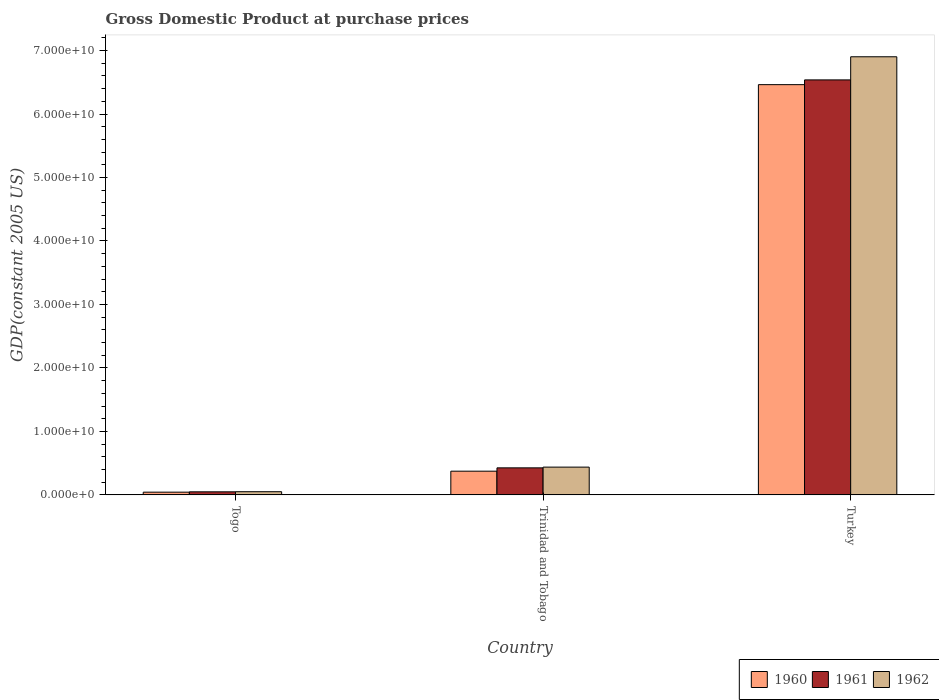How many different coloured bars are there?
Your response must be concise. 3. How many groups of bars are there?
Offer a terse response. 3. What is the label of the 3rd group of bars from the left?
Your answer should be very brief. Turkey. In how many cases, is the number of bars for a given country not equal to the number of legend labels?
Your response must be concise. 0. What is the GDP at purchase prices in 1962 in Trinidad and Tobago?
Make the answer very short. 4.38e+09. Across all countries, what is the maximum GDP at purchase prices in 1960?
Make the answer very short. 6.46e+1. Across all countries, what is the minimum GDP at purchase prices in 1961?
Your response must be concise. 4.83e+08. In which country was the GDP at purchase prices in 1960 maximum?
Provide a succinct answer. Turkey. In which country was the GDP at purchase prices in 1962 minimum?
Make the answer very short. Togo. What is the total GDP at purchase prices in 1960 in the graph?
Offer a terse response. 6.88e+1. What is the difference between the GDP at purchase prices in 1962 in Togo and that in Turkey?
Your answer should be compact. -6.85e+1. What is the difference between the GDP at purchase prices in 1960 in Turkey and the GDP at purchase prices in 1962 in Togo?
Your answer should be very brief. 6.41e+1. What is the average GDP at purchase prices in 1961 per country?
Ensure brevity in your answer.  2.34e+1. What is the difference between the GDP at purchase prices of/in 1962 and GDP at purchase prices of/in 1960 in Trinidad and Tobago?
Give a very brief answer. 6.41e+08. What is the ratio of the GDP at purchase prices in 1960 in Togo to that in Turkey?
Your answer should be compact. 0.01. Is the GDP at purchase prices in 1961 in Trinidad and Tobago less than that in Turkey?
Provide a succinct answer. Yes. Is the difference between the GDP at purchase prices in 1962 in Togo and Trinidad and Tobago greater than the difference between the GDP at purchase prices in 1960 in Togo and Trinidad and Tobago?
Keep it short and to the point. No. What is the difference between the highest and the second highest GDP at purchase prices in 1961?
Offer a terse response. 6.11e+1. What is the difference between the highest and the lowest GDP at purchase prices in 1960?
Ensure brevity in your answer.  6.42e+1. Is the sum of the GDP at purchase prices in 1960 in Togo and Turkey greater than the maximum GDP at purchase prices in 1962 across all countries?
Offer a terse response. No. Is it the case that in every country, the sum of the GDP at purchase prices in 1960 and GDP at purchase prices in 1961 is greater than the GDP at purchase prices in 1962?
Offer a very short reply. Yes. How many bars are there?
Offer a terse response. 9. Are all the bars in the graph horizontal?
Make the answer very short. No. Are the values on the major ticks of Y-axis written in scientific E-notation?
Offer a very short reply. Yes. Does the graph contain any zero values?
Provide a succinct answer. No. Does the graph contain grids?
Keep it short and to the point. No. Where does the legend appear in the graph?
Your answer should be compact. Bottom right. How many legend labels are there?
Ensure brevity in your answer.  3. How are the legend labels stacked?
Your answer should be very brief. Horizontal. What is the title of the graph?
Your answer should be very brief. Gross Domestic Product at purchase prices. Does "2001" appear as one of the legend labels in the graph?
Offer a terse response. No. What is the label or title of the Y-axis?
Provide a short and direct response. GDP(constant 2005 US). What is the GDP(constant 2005 US) of 1960 in Togo?
Offer a very short reply. 4.31e+08. What is the GDP(constant 2005 US) of 1961 in Togo?
Keep it short and to the point. 4.83e+08. What is the GDP(constant 2005 US) in 1962 in Togo?
Offer a terse response. 5.01e+08. What is the GDP(constant 2005 US) of 1960 in Trinidad and Tobago?
Ensure brevity in your answer.  3.74e+09. What is the GDP(constant 2005 US) in 1961 in Trinidad and Tobago?
Your response must be concise. 4.26e+09. What is the GDP(constant 2005 US) of 1962 in Trinidad and Tobago?
Your answer should be compact. 4.38e+09. What is the GDP(constant 2005 US) of 1960 in Turkey?
Your answer should be compact. 6.46e+1. What is the GDP(constant 2005 US) in 1961 in Turkey?
Your response must be concise. 6.54e+1. What is the GDP(constant 2005 US) of 1962 in Turkey?
Your response must be concise. 6.90e+1. Across all countries, what is the maximum GDP(constant 2005 US) in 1960?
Provide a succinct answer. 6.46e+1. Across all countries, what is the maximum GDP(constant 2005 US) of 1961?
Your answer should be compact. 6.54e+1. Across all countries, what is the maximum GDP(constant 2005 US) of 1962?
Your response must be concise. 6.90e+1. Across all countries, what is the minimum GDP(constant 2005 US) of 1960?
Make the answer very short. 4.31e+08. Across all countries, what is the minimum GDP(constant 2005 US) of 1961?
Your answer should be compact. 4.83e+08. Across all countries, what is the minimum GDP(constant 2005 US) in 1962?
Your answer should be very brief. 5.01e+08. What is the total GDP(constant 2005 US) of 1960 in the graph?
Keep it short and to the point. 6.88e+1. What is the total GDP(constant 2005 US) in 1961 in the graph?
Keep it short and to the point. 7.01e+1. What is the total GDP(constant 2005 US) in 1962 in the graph?
Keep it short and to the point. 7.39e+1. What is the difference between the GDP(constant 2005 US) of 1960 in Togo and that in Trinidad and Tobago?
Ensure brevity in your answer.  -3.30e+09. What is the difference between the GDP(constant 2005 US) of 1961 in Togo and that in Trinidad and Tobago?
Keep it short and to the point. -3.78e+09. What is the difference between the GDP(constant 2005 US) in 1962 in Togo and that in Trinidad and Tobago?
Keep it short and to the point. -3.88e+09. What is the difference between the GDP(constant 2005 US) of 1960 in Togo and that in Turkey?
Give a very brief answer. -6.42e+1. What is the difference between the GDP(constant 2005 US) in 1961 in Togo and that in Turkey?
Offer a terse response. -6.49e+1. What is the difference between the GDP(constant 2005 US) in 1962 in Togo and that in Turkey?
Your response must be concise. -6.85e+1. What is the difference between the GDP(constant 2005 US) in 1960 in Trinidad and Tobago and that in Turkey?
Offer a very short reply. -6.09e+1. What is the difference between the GDP(constant 2005 US) in 1961 in Trinidad and Tobago and that in Turkey?
Provide a short and direct response. -6.11e+1. What is the difference between the GDP(constant 2005 US) in 1962 in Trinidad and Tobago and that in Turkey?
Make the answer very short. -6.46e+1. What is the difference between the GDP(constant 2005 US) in 1960 in Togo and the GDP(constant 2005 US) in 1961 in Trinidad and Tobago?
Ensure brevity in your answer.  -3.83e+09. What is the difference between the GDP(constant 2005 US) of 1960 in Togo and the GDP(constant 2005 US) of 1962 in Trinidad and Tobago?
Offer a very short reply. -3.95e+09. What is the difference between the GDP(constant 2005 US) of 1961 in Togo and the GDP(constant 2005 US) of 1962 in Trinidad and Tobago?
Offer a terse response. -3.89e+09. What is the difference between the GDP(constant 2005 US) of 1960 in Togo and the GDP(constant 2005 US) of 1961 in Turkey?
Keep it short and to the point. -6.49e+1. What is the difference between the GDP(constant 2005 US) in 1960 in Togo and the GDP(constant 2005 US) in 1962 in Turkey?
Your answer should be very brief. -6.86e+1. What is the difference between the GDP(constant 2005 US) in 1961 in Togo and the GDP(constant 2005 US) in 1962 in Turkey?
Make the answer very short. -6.85e+1. What is the difference between the GDP(constant 2005 US) in 1960 in Trinidad and Tobago and the GDP(constant 2005 US) in 1961 in Turkey?
Offer a very short reply. -6.16e+1. What is the difference between the GDP(constant 2005 US) in 1960 in Trinidad and Tobago and the GDP(constant 2005 US) in 1962 in Turkey?
Offer a terse response. -6.53e+1. What is the difference between the GDP(constant 2005 US) in 1961 in Trinidad and Tobago and the GDP(constant 2005 US) in 1962 in Turkey?
Your response must be concise. -6.48e+1. What is the average GDP(constant 2005 US) of 1960 per country?
Offer a terse response. 2.29e+1. What is the average GDP(constant 2005 US) of 1961 per country?
Ensure brevity in your answer.  2.34e+1. What is the average GDP(constant 2005 US) of 1962 per country?
Keep it short and to the point. 2.46e+1. What is the difference between the GDP(constant 2005 US) in 1960 and GDP(constant 2005 US) in 1961 in Togo?
Make the answer very short. -5.24e+07. What is the difference between the GDP(constant 2005 US) in 1960 and GDP(constant 2005 US) in 1962 in Togo?
Ensure brevity in your answer.  -7.06e+07. What is the difference between the GDP(constant 2005 US) of 1961 and GDP(constant 2005 US) of 1962 in Togo?
Keep it short and to the point. -1.82e+07. What is the difference between the GDP(constant 2005 US) of 1960 and GDP(constant 2005 US) of 1961 in Trinidad and Tobago?
Provide a succinct answer. -5.24e+08. What is the difference between the GDP(constant 2005 US) of 1960 and GDP(constant 2005 US) of 1962 in Trinidad and Tobago?
Provide a succinct answer. -6.41e+08. What is the difference between the GDP(constant 2005 US) in 1961 and GDP(constant 2005 US) in 1962 in Trinidad and Tobago?
Provide a succinct answer. -1.17e+08. What is the difference between the GDP(constant 2005 US) in 1960 and GDP(constant 2005 US) in 1961 in Turkey?
Ensure brevity in your answer.  -7.47e+08. What is the difference between the GDP(constant 2005 US) in 1960 and GDP(constant 2005 US) in 1962 in Turkey?
Give a very brief answer. -4.39e+09. What is the difference between the GDP(constant 2005 US) of 1961 and GDP(constant 2005 US) of 1962 in Turkey?
Ensure brevity in your answer.  -3.64e+09. What is the ratio of the GDP(constant 2005 US) in 1960 in Togo to that in Trinidad and Tobago?
Keep it short and to the point. 0.12. What is the ratio of the GDP(constant 2005 US) of 1961 in Togo to that in Trinidad and Tobago?
Make the answer very short. 0.11. What is the ratio of the GDP(constant 2005 US) in 1962 in Togo to that in Trinidad and Tobago?
Your answer should be very brief. 0.11. What is the ratio of the GDP(constant 2005 US) of 1960 in Togo to that in Turkey?
Your response must be concise. 0.01. What is the ratio of the GDP(constant 2005 US) of 1961 in Togo to that in Turkey?
Your answer should be compact. 0.01. What is the ratio of the GDP(constant 2005 US) of 1962 in Togo to that in Turkey?
Your answer should be very brief. 0.01. What is the ratio of the GDP(constant 2005 US) of 1960 in Trinidad and Tobago to that in Turkey?
Ensure brevity in your answer.  0.06. What is the ratio of the GDP(constant 2005 US) of 1961 in Trinidad and Tobago to that in Turkey?
Provide a succinct answer. 0.07. What is the ratio of the GDP(constant 2005 US) of 1962 in Trinidad and Tobago to that in Turkey?
Provide a short and direct response. 0.06. What is the difference between the highest and the second highest GDP(constant 2005 US) in 1960?
Offer a terse response. 6.09e+1. What is the difference between the highest and the second highest GDP(constant 2005 US) of 1961?
Offer a terse response. 6.11e+1. What is the difference between the highest and the second highest GDP(constant 2005 US) in 1962?
Give a very brief answer. 6.46e+1. What is the difference between the highest and the lowest GDP(constant 2005 US) in 1960?
Ensure brevity in your answer.  6.42e+1. What is the difference between the highest and the lowest GDP(constant 2005 US) in 1961?
Give a very brief answer. 6.49e+1. What is the difference between the highest and the lowest GDP(constant 2005 US) of 1962?
Provide a succinct answer. 6.85e+1. 